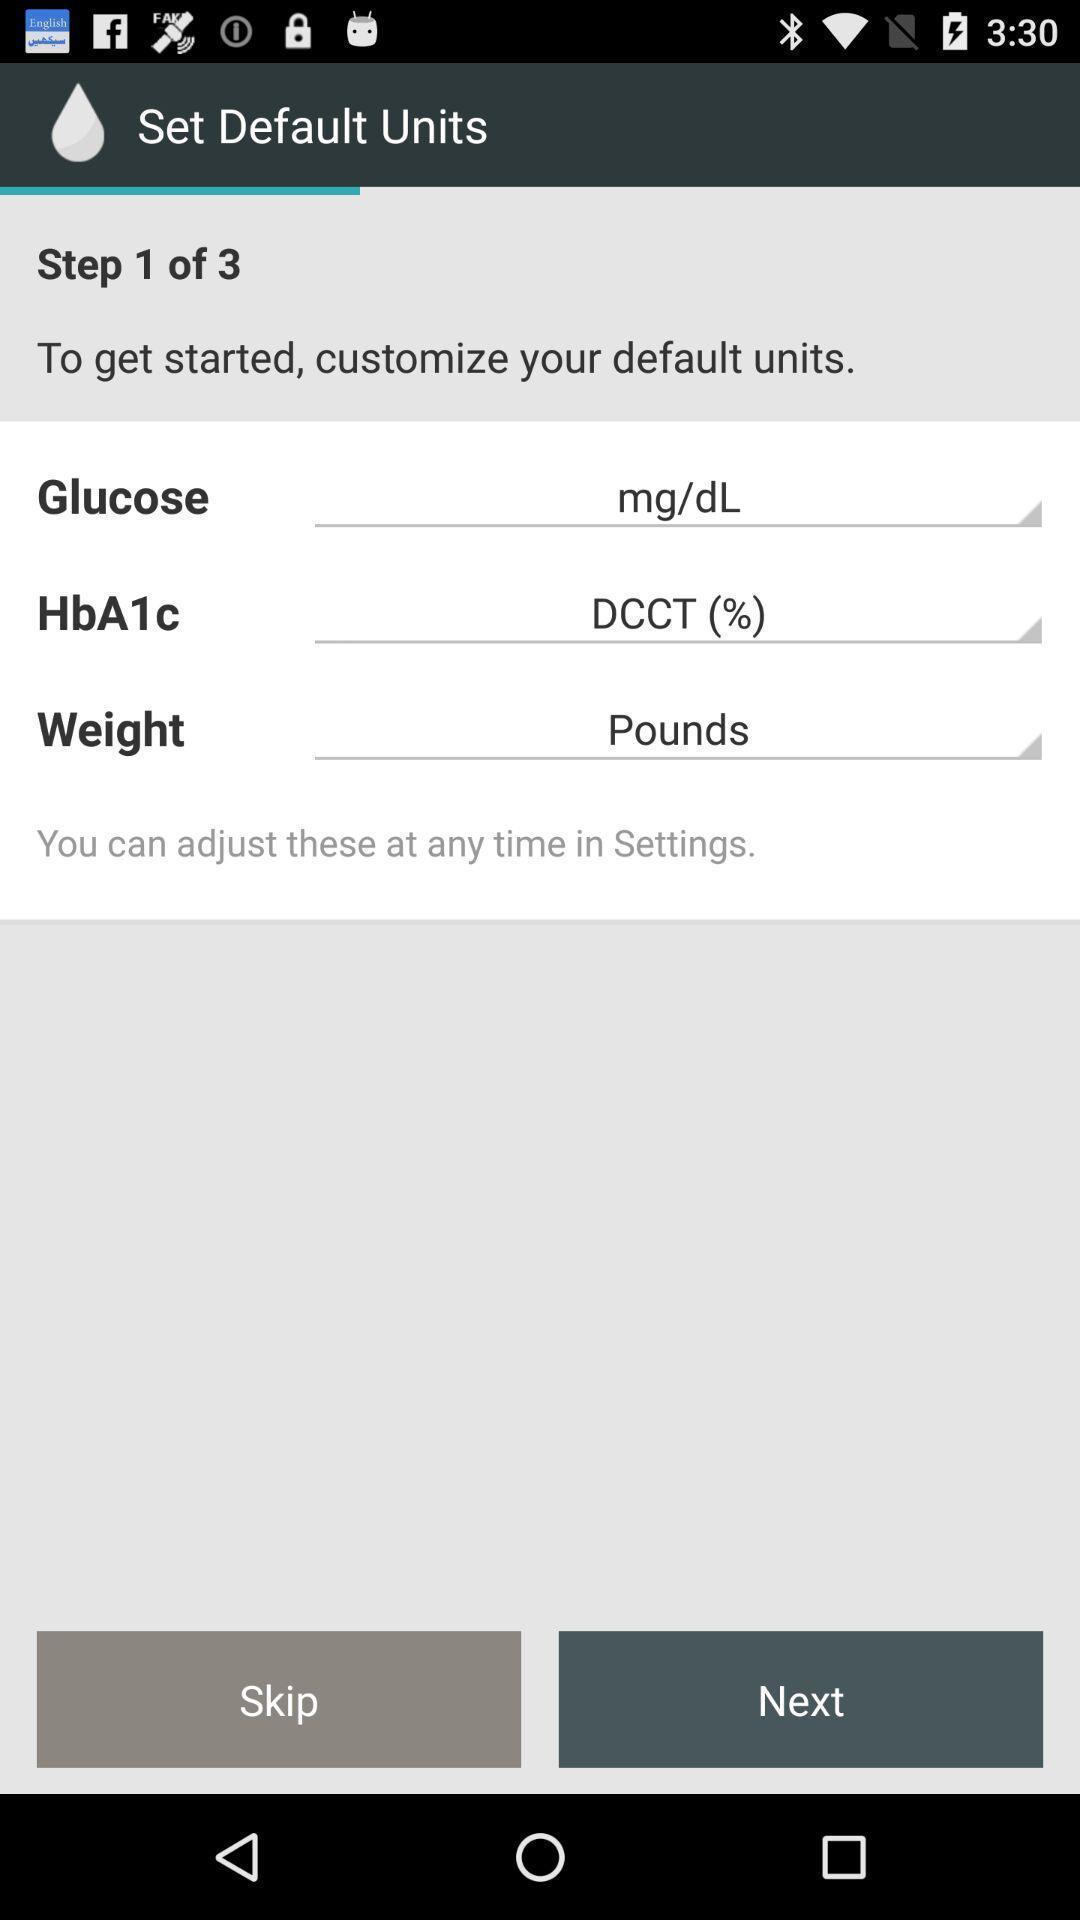Describe the content in this image. Page with body and glucose details for diabetes tracking app. 